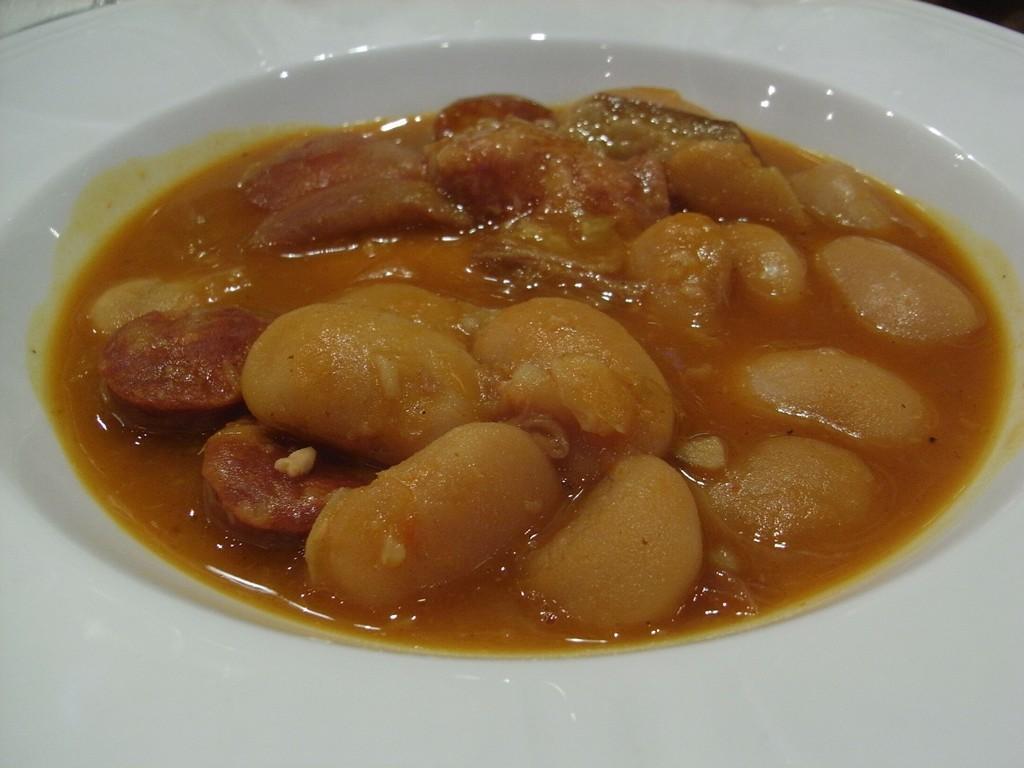In one or two sentences, can you explain what this image depicts? In this image I can see the food in the plate. The food is in brown color. 